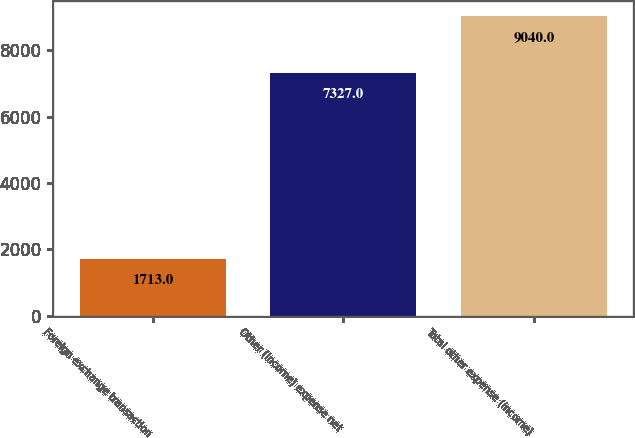Convert chart to OTSL. <chart><loc_0><loc_0><loc_500><loc_500><bar_chart><fcel>Foreign exchange transaction<fcel>Other (income) expense net<fcel>Total other expense (income)<nl><fcel>1713<fcel>7327<fcel>9040<nl></chart> 